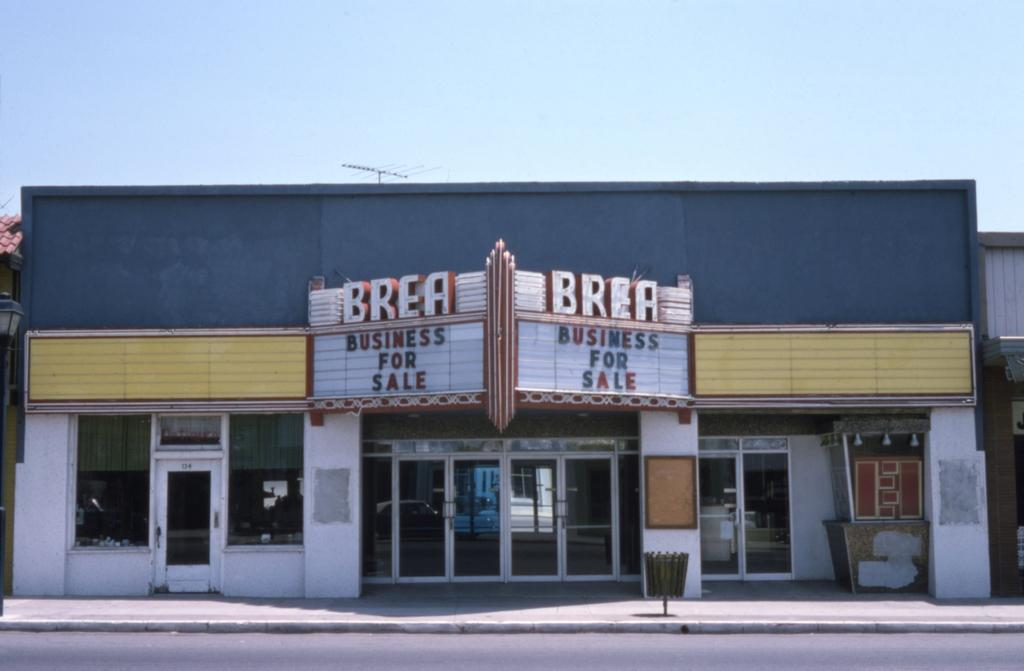What type of structures are visible in the image? There are buildings with windows in the image. What can be seen on the buildings? There are name boards on the buildings. What mode of transportation is present on the road in the image? There is a car on the road in the image. What can be seen in the background of the image? The sky is visible in the background of the image. What type of yard can be seen in the image? There is no yard present in the image; it features buildings, a car, and the sky. Can you describe the smile on the car's face in the image? Cars do not have faces or the ability to smile, so this detail cannot be found in the image. 